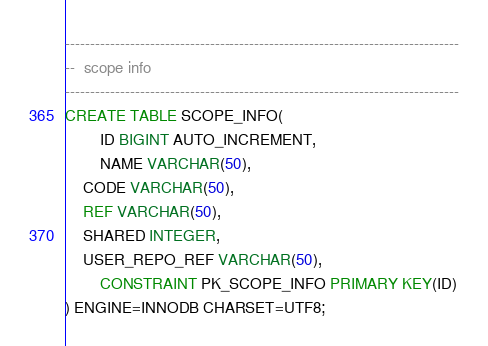<code> <loc_0><loc_0><loc_500><loc_500><_SQL_>

-------------------------------------------------------------------------------
--  scope info
-------------------------------------------------------------------------------
CREATE TABLE SCOPE_INFO(
        ID BIGINT AUTO_INCREMENT,
        NAME VARCHAR(50),
	CODE VARCHAR(50),
	REF VARCHAR(50),
	SHARED INTEGER,
	USER_REPO_REF VARCHAR(50),
        CONSTRAINT PK_SCOPE_INFO PRIMARY KEY(ID)
) ENGINE=INNODB CHARSET=UTF8;

</code> 